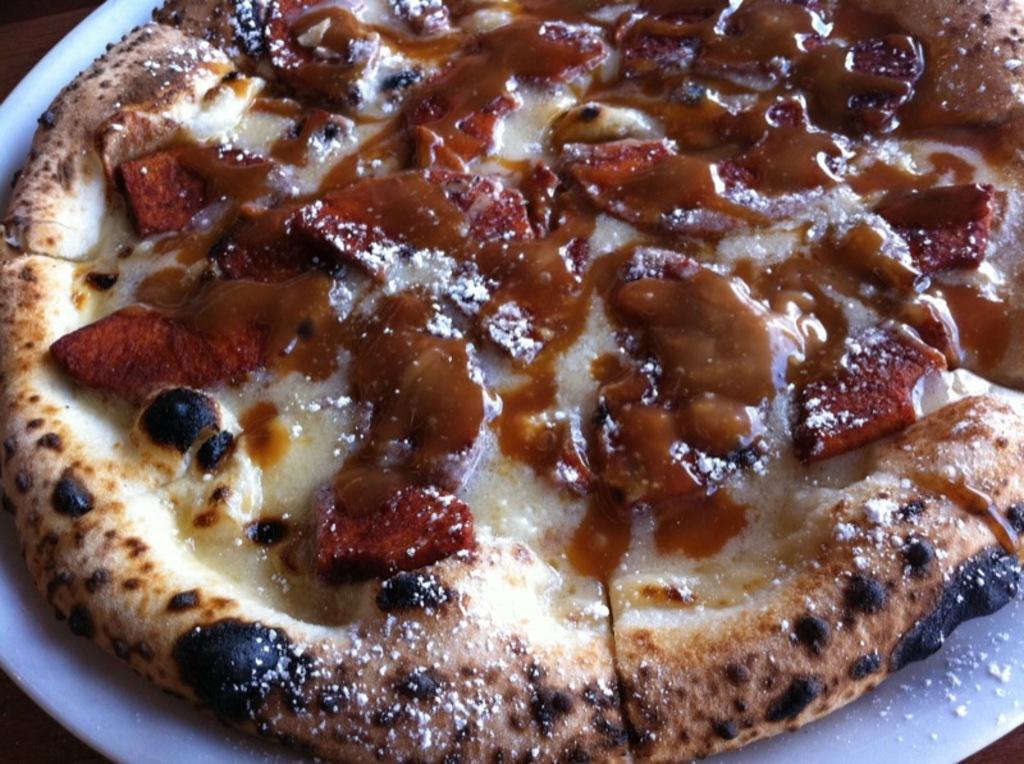Describe this image in one or two sentences. In the image we can see a plate, white in color. On the plate there are slices of pizza. 